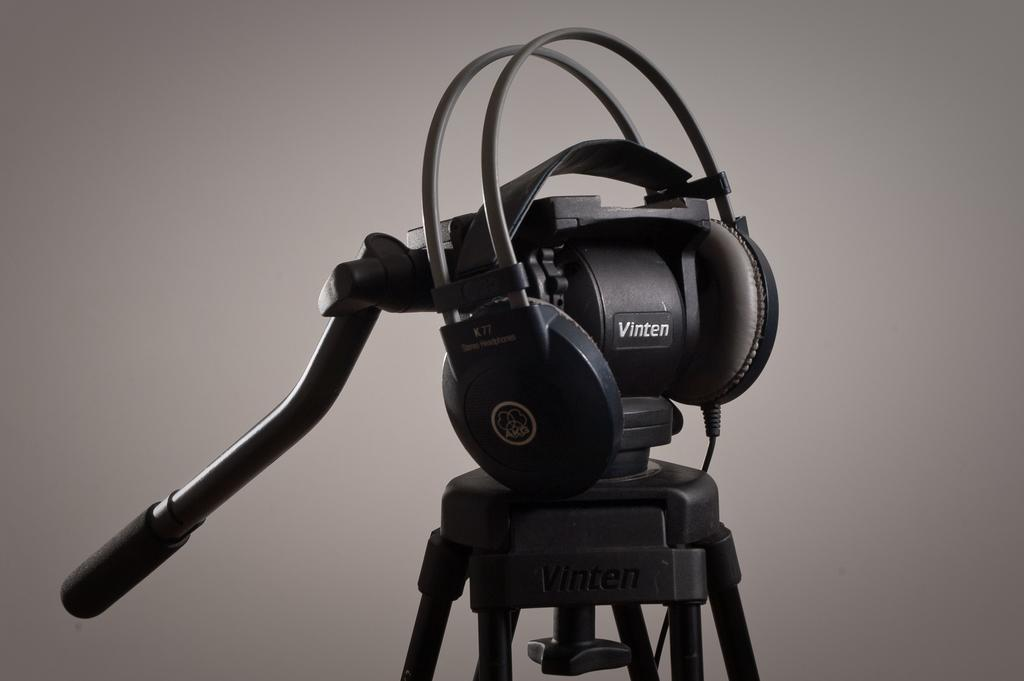What type of equipment is visible in the image? There is a headset, a camera stand, and a microphone (mic) in the image. What is used to connect the equipment in the image? There is a cable in the image for connecting the equipment. What is the color of the background in the image? The background of the image is in ash color. What type of food is being prepared on the hook in the image? There is no hook or food preparation visible in the image. How many people are sleeping in the image? There are no people sleeping in the image. 